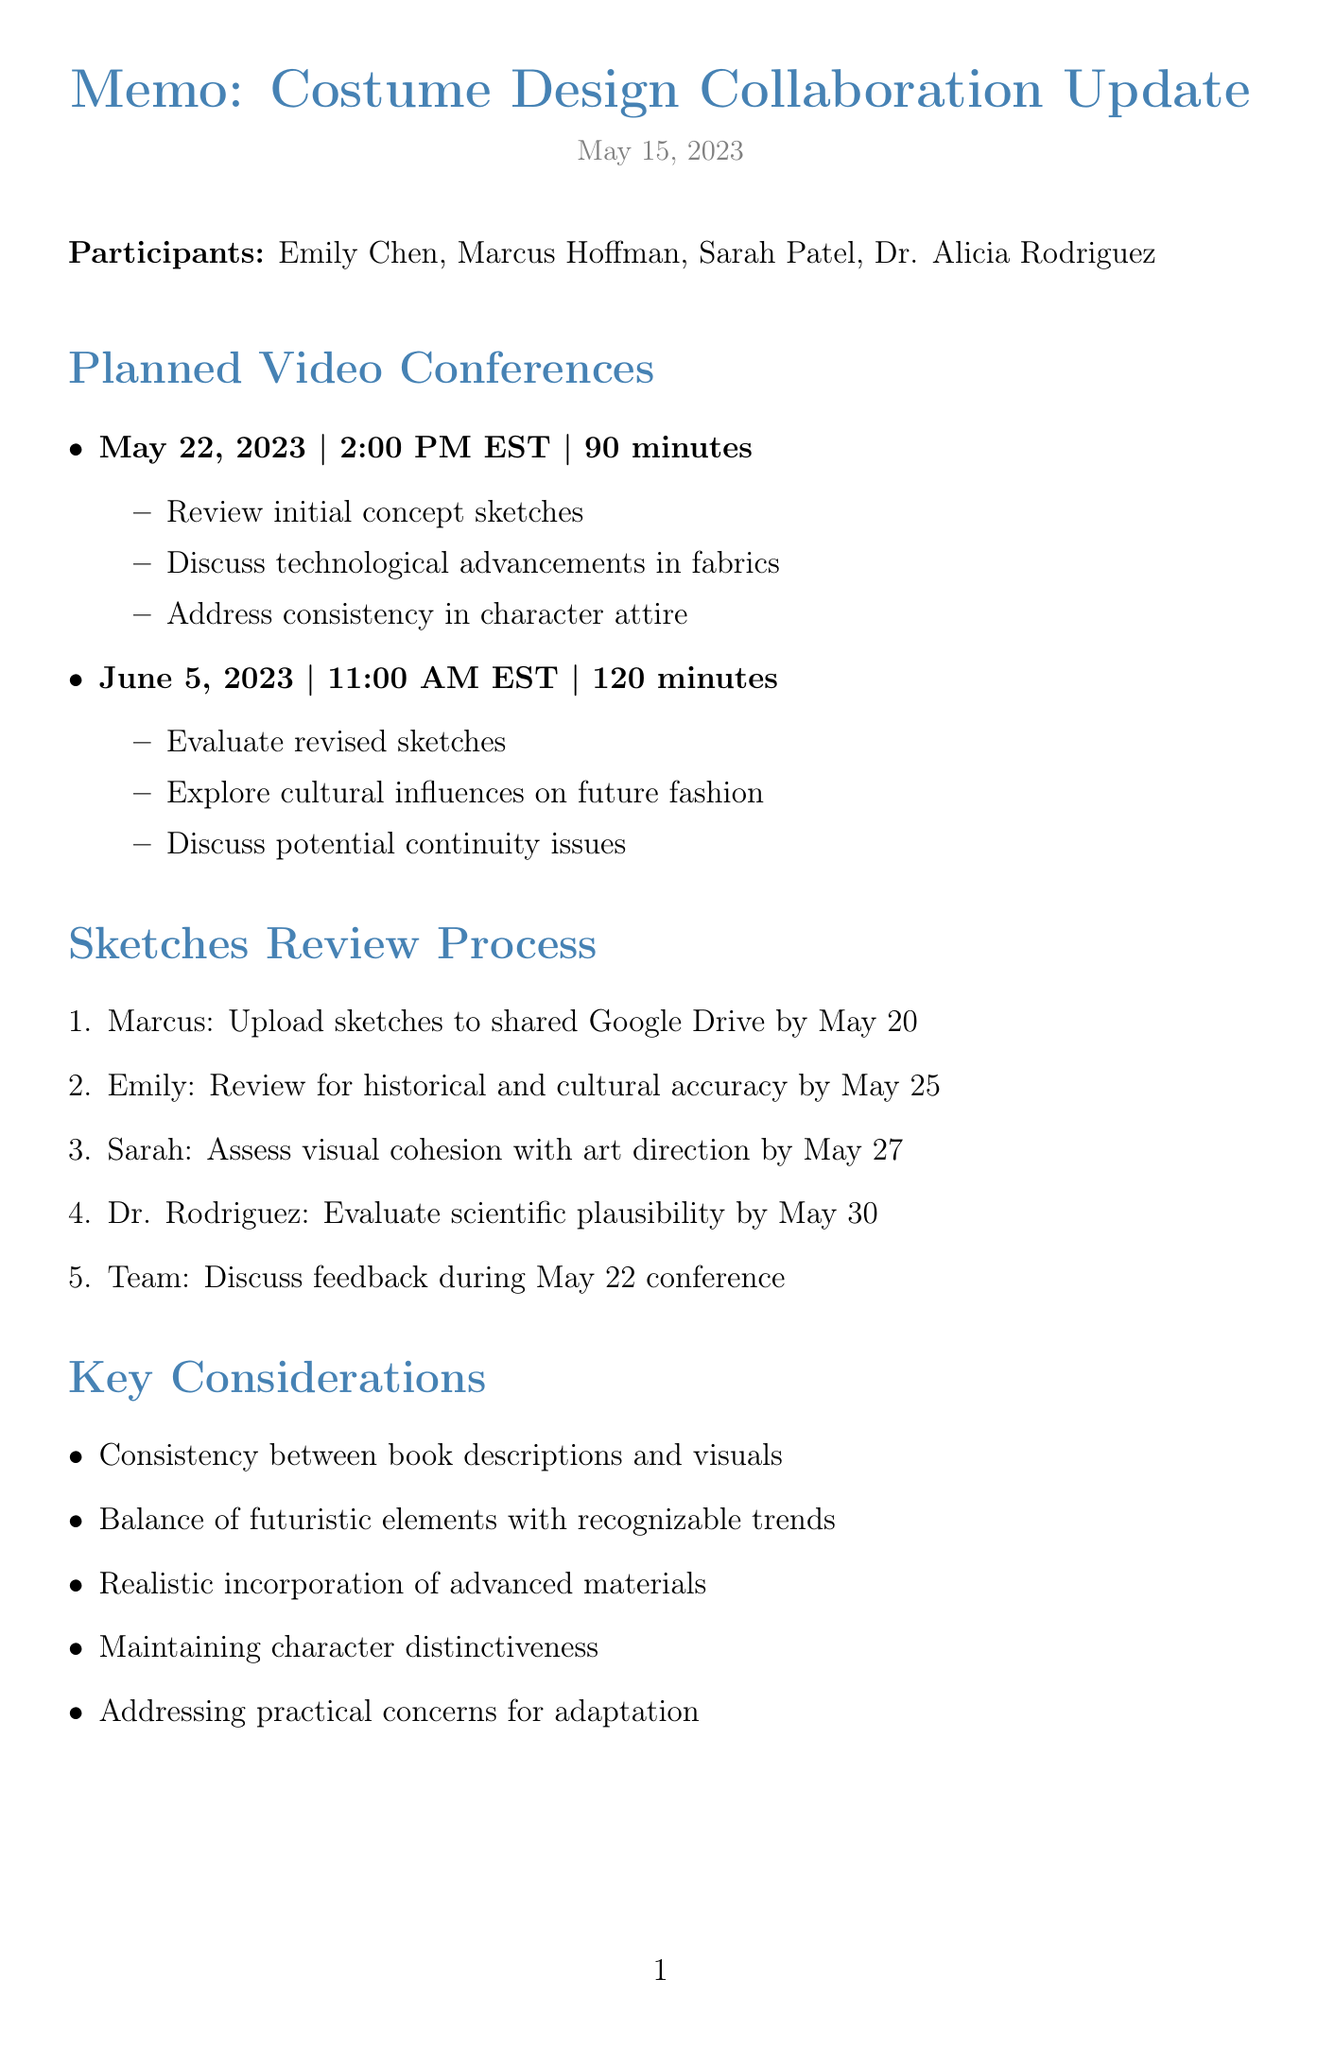What is the date of the first video conference? The date of the first video conference is listed in the planned video conferences section of the document.
Answer: May 22, 2023 Who is responsible for assessing visual cohesion with overall art direction? The responsibility for assessing visual cohesion is allocated in the sketches review process section.
Answer: Sarah What is the duration of the second video conference? The duration is specified under the planned video conferences section of the memo.
Answer: 120 minutes What key consideration involves futuristic elements and recognizable trends? The key considerations are outlined in a bullet list within the document.
Answer: Balance of futuristic elements with recognizable trends By what date is Emily expected to review sketches for historical accuracy? The expected review date is noted in the sketches review process section of the memo.
Answer: May 25 Which character description is Emily compiling? This task is stated in the action items section of the document.
Answer: Character descriptions from the novels What is the main agenda item for the May 22 video conference? The main agenda item is the first entry in the agenda for the first video conference.
Answer: Review initial concept sketches for main characters What deadline is set for Dr. Rodriguez to evaluate scientific plausibility? The deadline is mentioned in the sketches review process section.
Answer: May 30 